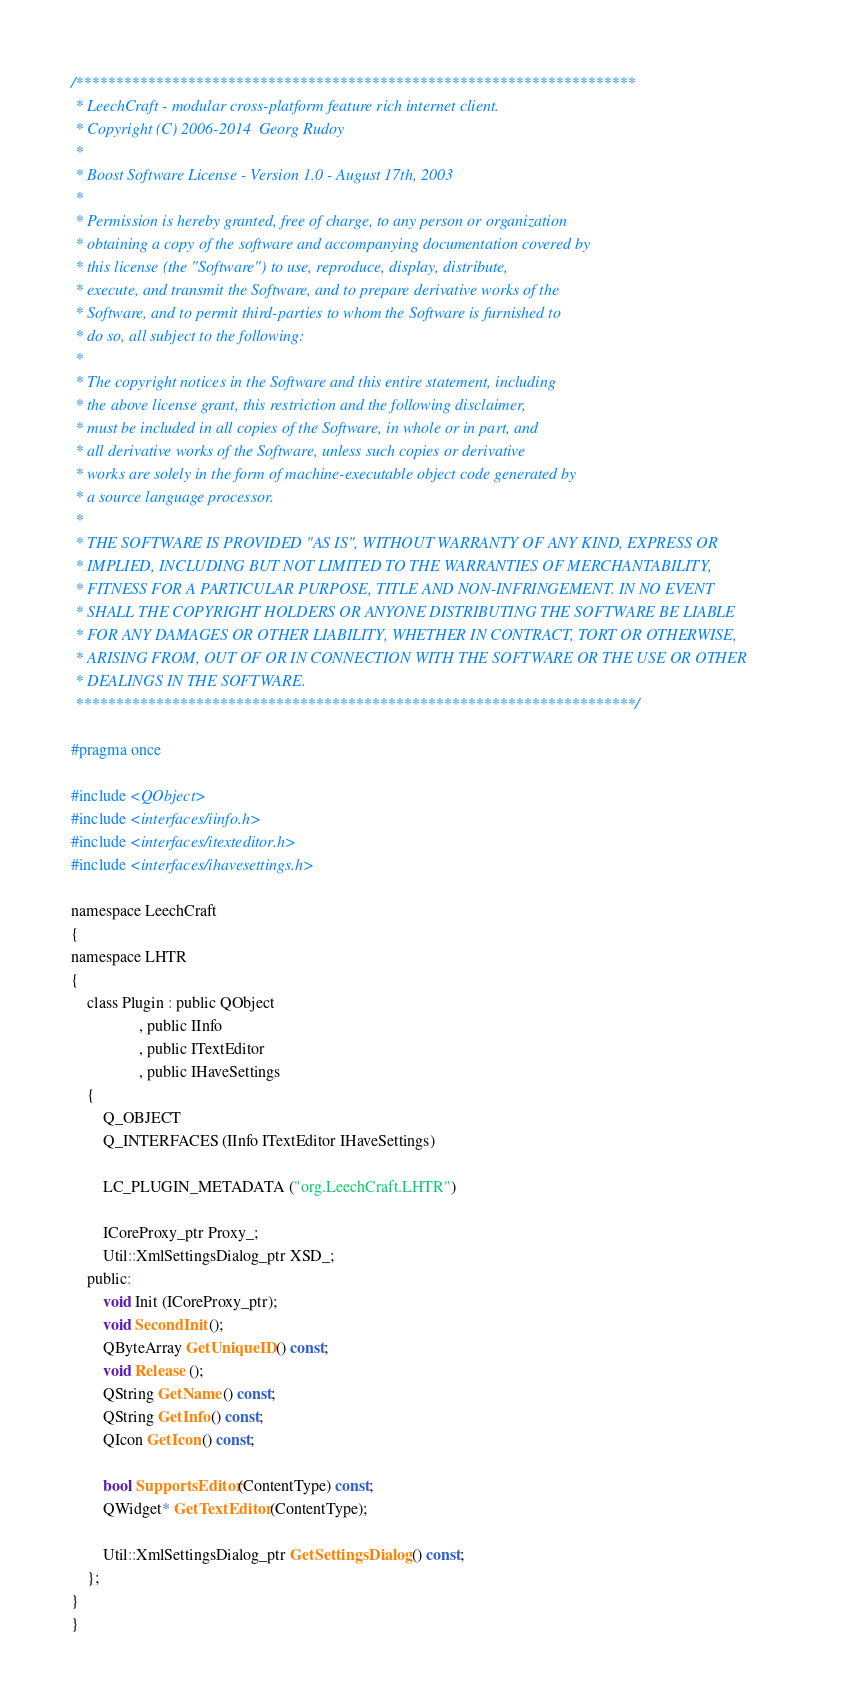Convert code to text. <code><loc_0><loc_0><loc_500><loc_500><_C_>/**********************************************************************
 * LeechCraft - modular cross-platform feature rich internet client.
 * Copyright (C) 2006-2014  Georg Rudoy
 *
 * Boost Software License - Version 1.0 - August 17th, 2003
 *
 * Permission is hereby granted, free of charge, to any person or organization
 * obtaining a copy of the software and accompanying documentation covered by
 * this license (the "Software") to use, reproduce, display, distribute,
 * execute, and transmit the Software, and to prepare derivative works of the
 * Software, and to permit third-parties to whom the Software is furnished to
 * do so, all subject to the following:
 *
 * The copyright notices in the Software and this entire statement, including
 * the above license grant, this restriction and the following disclaimer,
 * must be included in all copies of the Software, in whole or in part, and
 * all derivative works of the Software, unless such copies or derivative
 * works are solely in the form of machine-executable object code generated by
 * a source language processor.
 *
 * THE SOFTWARE IS PROVIDED "AS IS", WITHOUT WARRANTY OF ANY KIND, EXPRESS OR
 * IMPLIED, INCLUDING BUT NOT LIMITED TO THE WARRANTIES OF MERCHANTABILITY,
 * FITNESS FOR A PARTICULAR PURPOSE, TITLE AND NON-INFRINGEMENT. IN NO EVENT
 * SHALL THE COPYRIGHT HOLDERS OR ANYONE DISTRIBUTING THE SOFTWARE BE LIABLE
 * FOR ANY DAMAGES OR OTHER LIABILITY, WHETHER IN CONTRACT, TORT OR OTHERWISE,
 * ARISING FROM, OUT OF OR IN CONNECTION WITH THE SOFTWARE OR THE USE OR OTHER
 * DEALINGS IN THE SOFTWARE.
 **********************************************************************/

#pragma once

#include <QObject>
#include <interfaces/iinfo.h>
#include <interfaces/itexteditor.h>
#include <interfaces/ihavesettings.h>

namespace LeechCraft
{
namespace LHTR
{
	class Plugin : public QObject
				 , public IInfo
				 , public ITextEditor
				 , public IHaveSettings
	{
		Q_OBJECT
		Q_INTERFACES (IInfo ITextEditor IHaveSettings)

		LC_PLUGIN_METADATA ("org.LeechCraft.LHTR")

		ICoreProxy_ptr Proxy_;
		Util::XmlSettingsDialog_ptr XSD_;
	public:
		void Init (ICoreProxy_ptr);
		void SecondInit ();
		QByteArray GetUniqueID () const;
		void Release ();
		QString GetName () const;
		QString GetInfo () const;
		QIcon GetIcon () const;

		bool SupportsEditor (ContentType) const;
		QWidget* GetTextEditor (ContentType);

		Util::XmlSettingsDialog_ptr GetSettingsDialog () const;
	};
}
}
</code> 